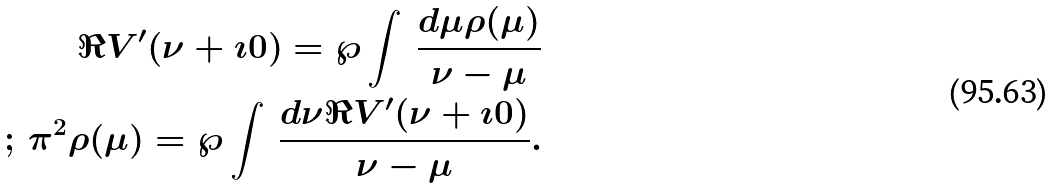<formula> <loc_0><loc_0><loc_500><loc_500>\Re V ^ { \prime } ( \nu + \imath 0 ) = \wp \int \, \frac { d \mu \rho ( \mu ) } { \nu - \mu } \\ ; \, \pi ^ { 2 } \rho ( \mu ) = \wp \int \, \frac { d \nu \Re V ^ { \prime } ( \nu + \imath 0 ) } { \nu - \mu } .</formula> 